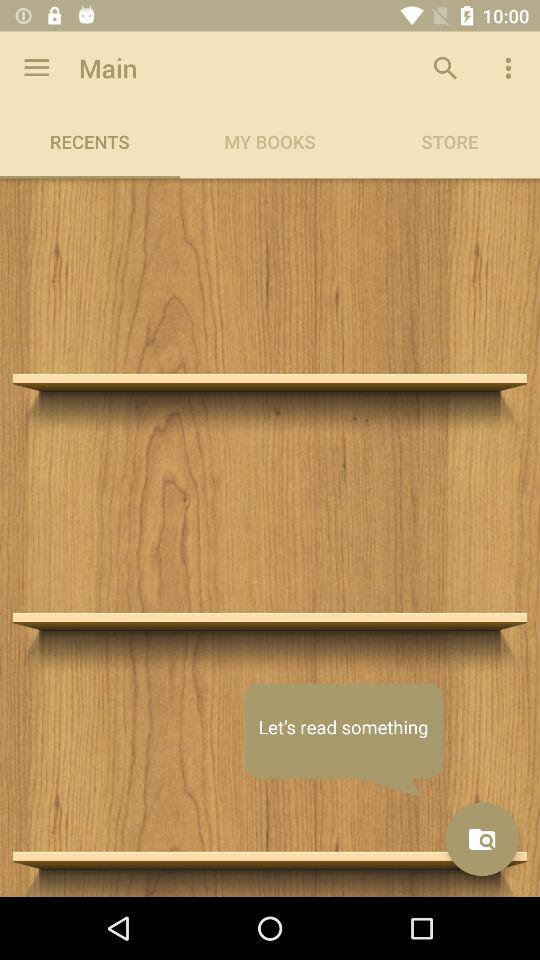On which tab am I now? The tab is "RECENTS". 